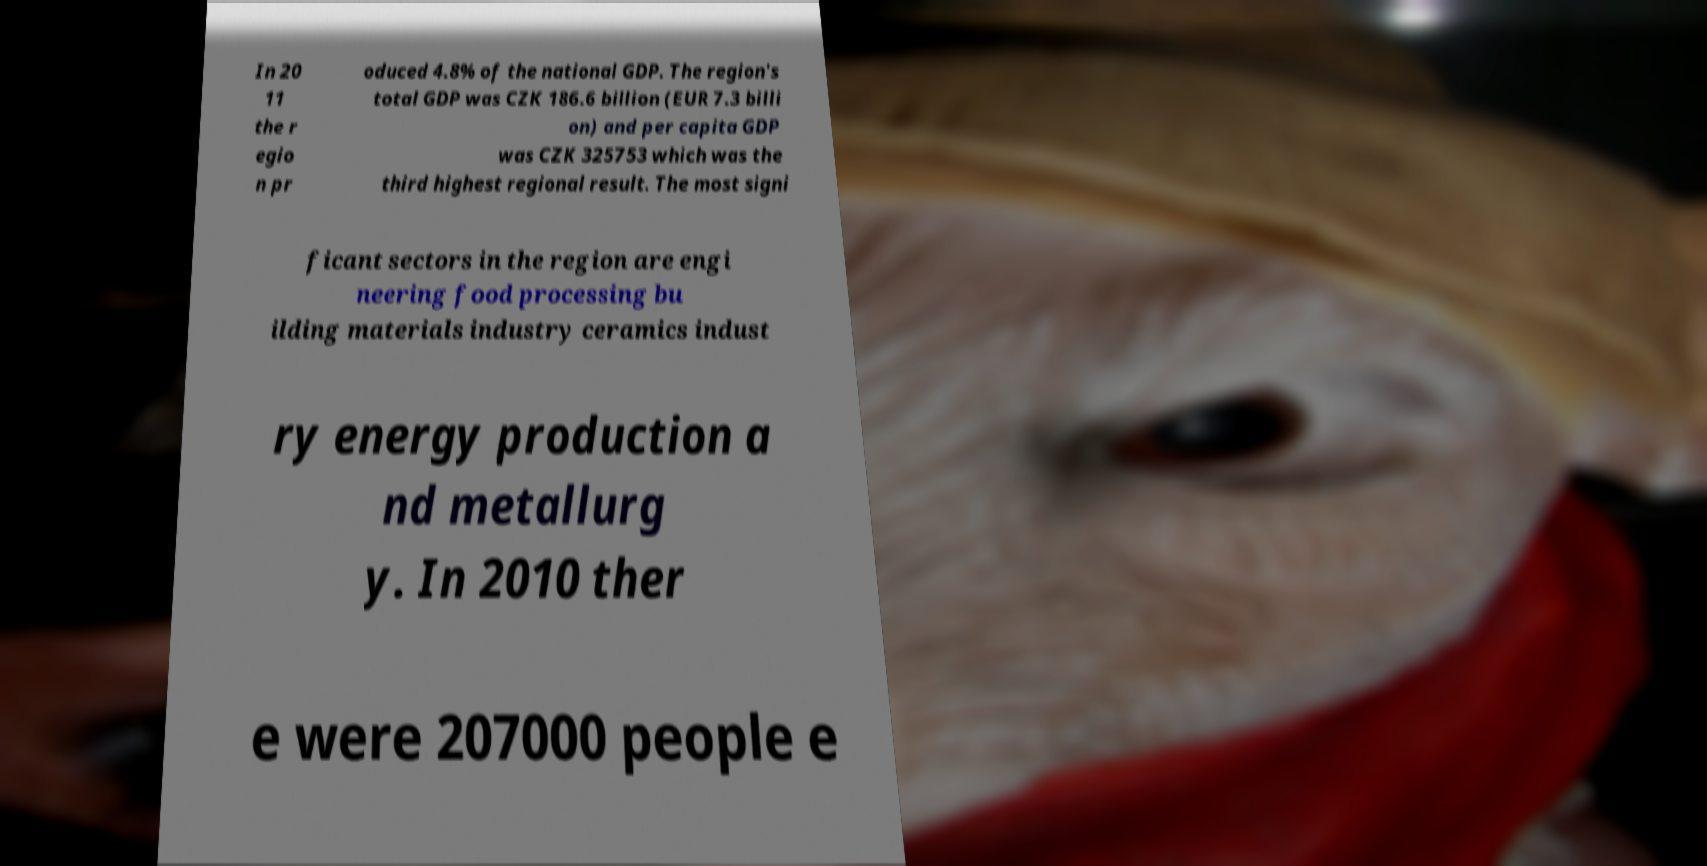Could you assist in decoding the text presented in this image and type it out clearly? In 20 11 the r egio n pr oduced 4.8% of the national GDP. The region's total GDP was CZK 186.6 billion (EUR 7.3 billi on) and per capita GDP was CZK 325753 which was the third highest regional result. The most signi ficant sectors in the region are engi neering food processing bu ilding materials industry ceramics indust ry energy production a nd metallurg y. In 2010 ther e were 207000 people e 